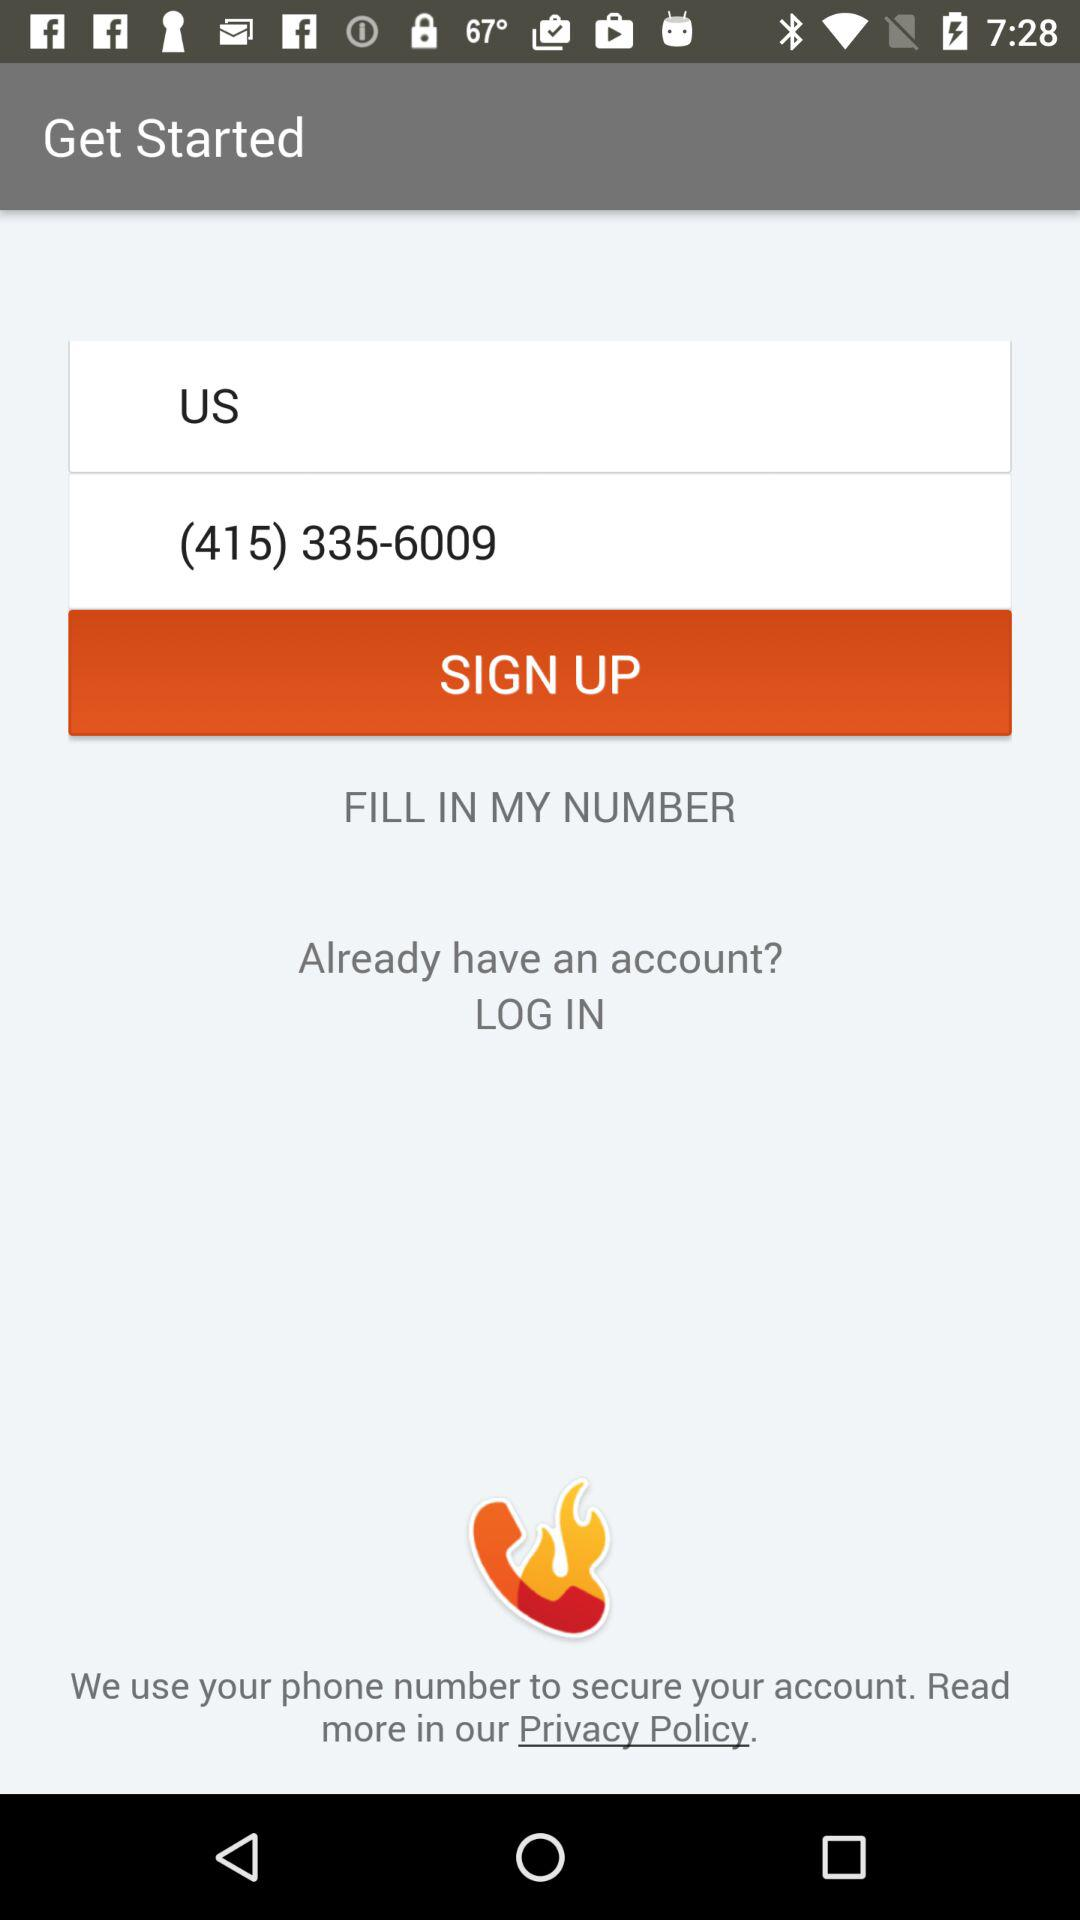What is the contact number? The contact number is (415) 335-6009. 